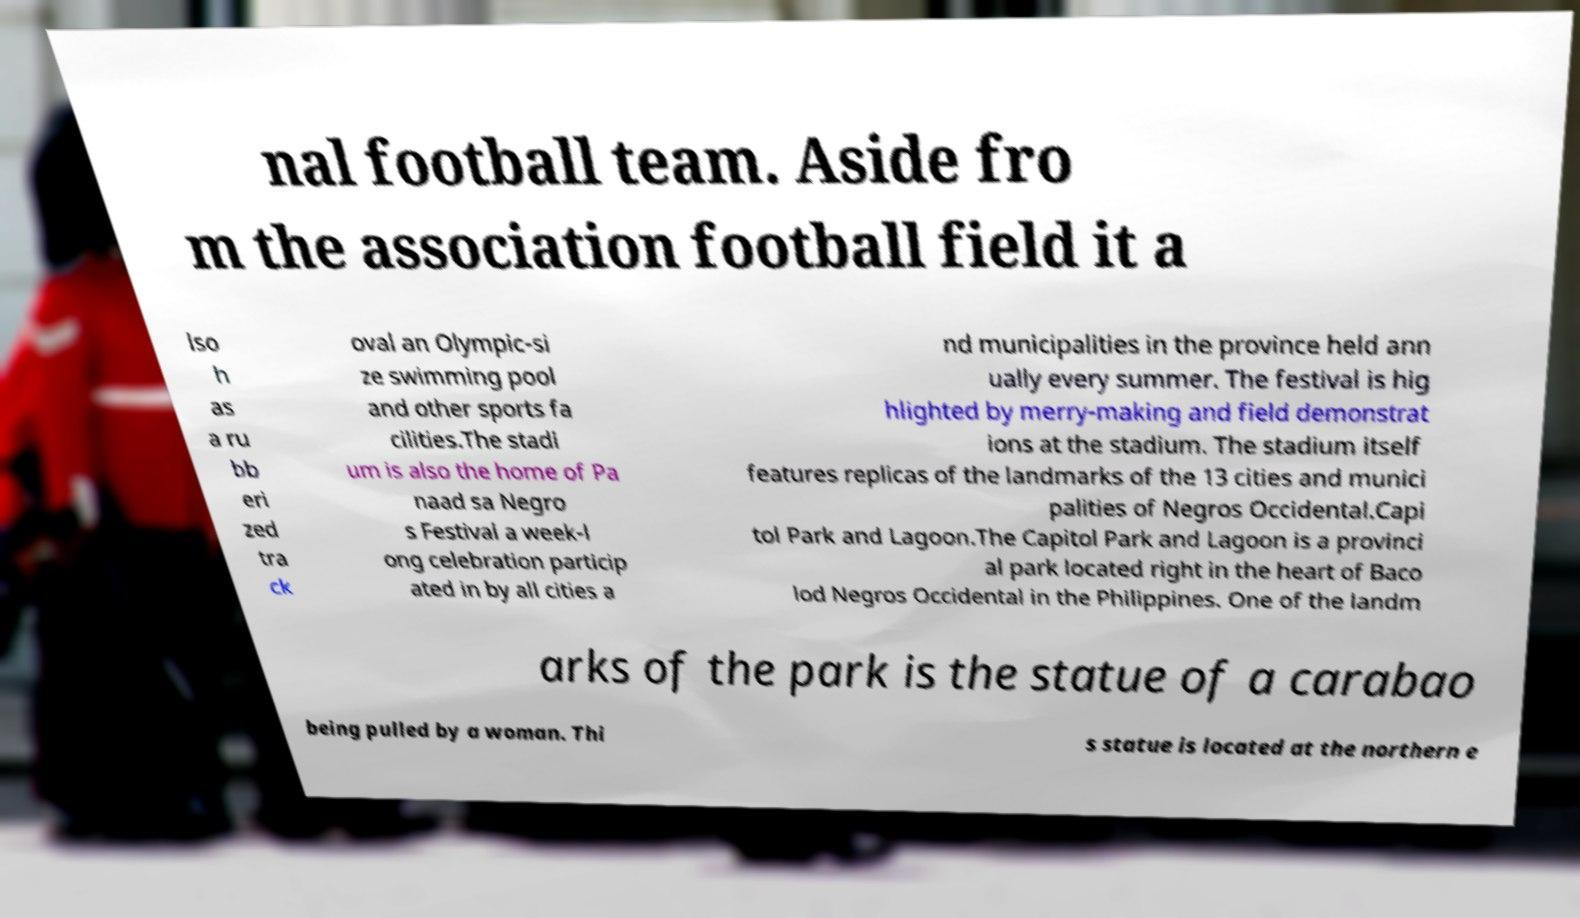Can you read and provide the text displayed in the image?This photo seems to have some interesting text. Can you extract and type it out for me? nal football team. Aside fro m the association football field it a lso h as a ru bb eri zed tra ck oval an Olympic-si ze swimming pool and other sports fa cilities.The stadi um is also the home of Pa naad sa Negro s Festival a week-l ong celebration particip ated in by all cities a nd municipalities in the province held ann ually every summer. The festival is hig hlighted by merry-making and field demonstrat ions at the stadium. The stadium itself features replicas of the landmarks of the 13 cities and munici palities of Negros Occidental.Capi tol Park and Lagoon.The Capitol Park and Lagoon is a provinci al park located right in the heart of Baco lod Negros Occidental in the Philippines. One of the landm arks of the park is the statue of a carabao being pulled by a woman. Thi s statue is located at the northern e 